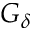<formula> <loc_0><loc_0><loc_500><loc_500>G _ { \delta }</formula> 